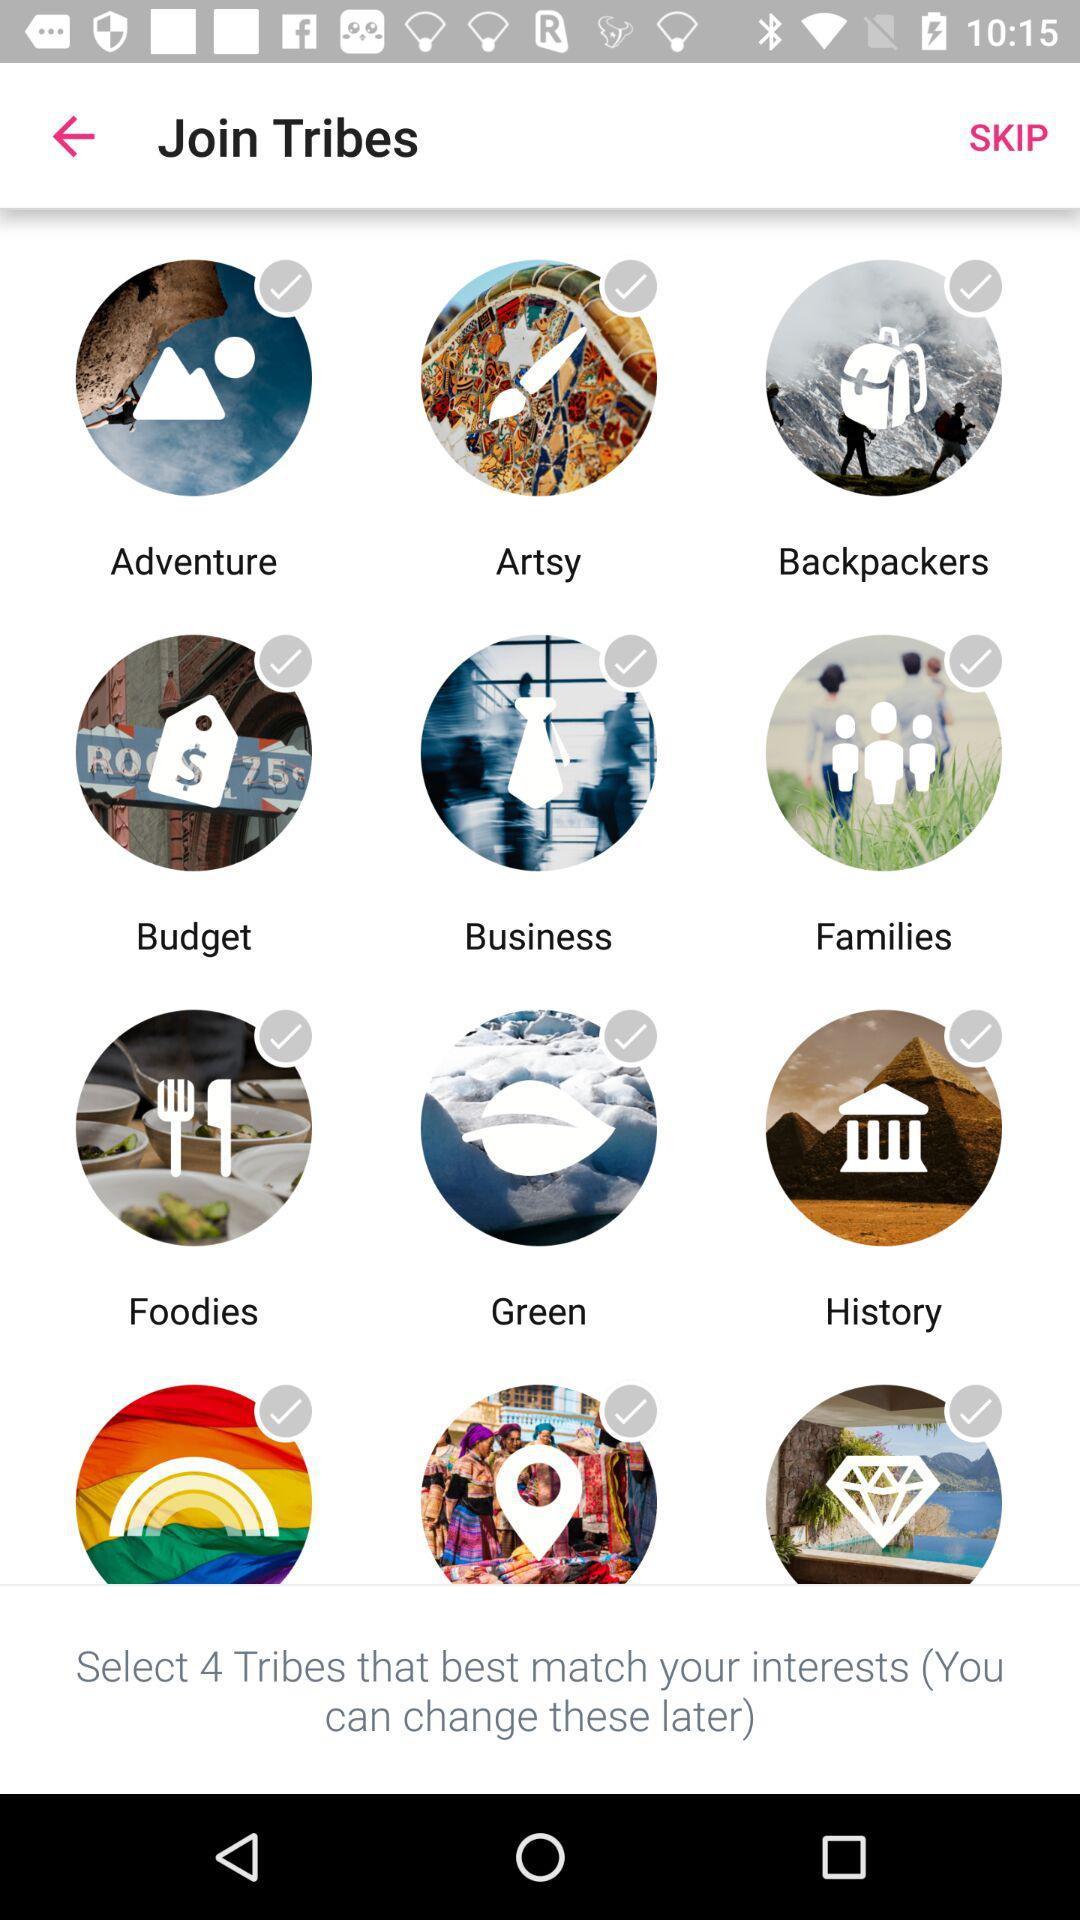How many tribes are there in total?
Answer the question using a single word or phrase. 12 